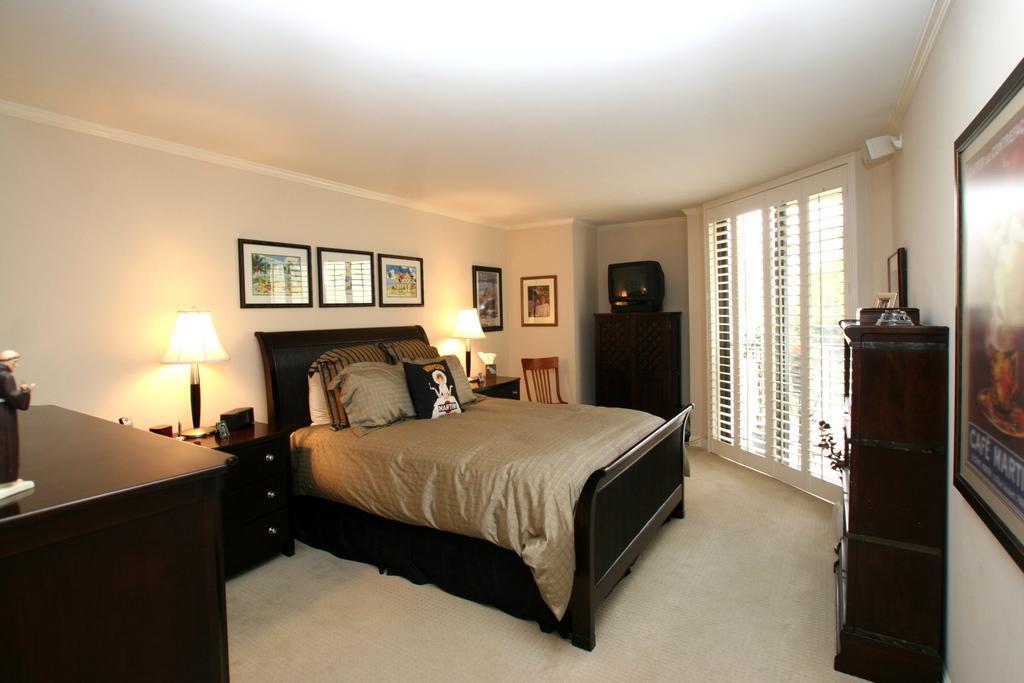How would you summarize this image in a sentence or two? In this image we can see a bed and pillows. Beside the bed there are few tables and there are few objects on the tables. Behind the bed we can see a wall on which there are few photo frames and at the top we can see the roof. On the right side of the image we can see a window, table and a frame on the wall. 